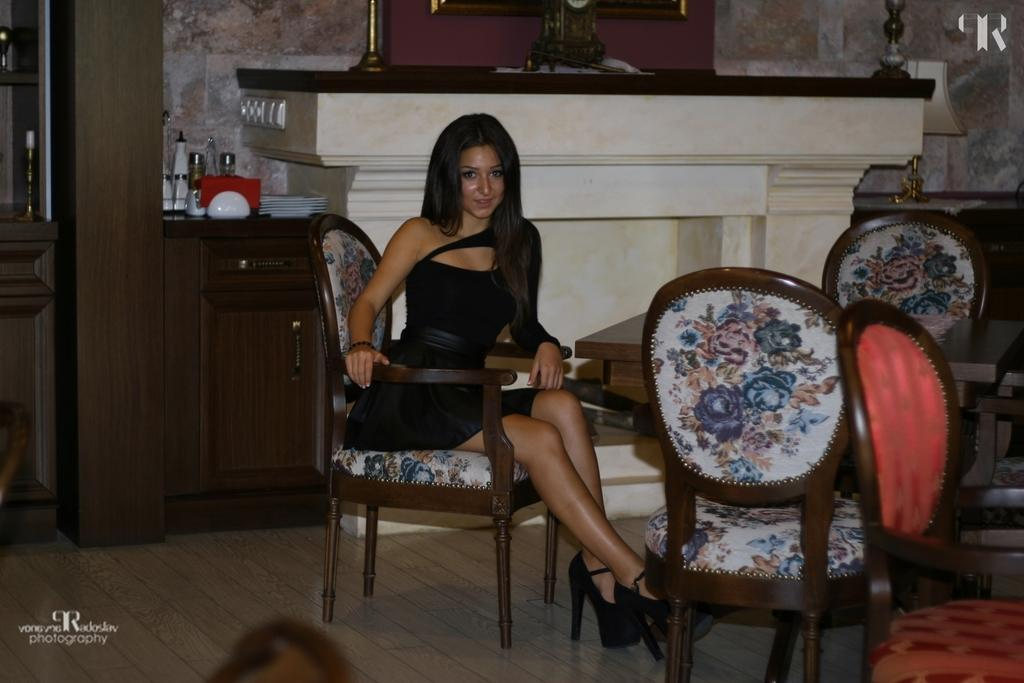Who is present in the image? There is a woman in the image. What is the woman doing in the image? The woman is seated on a chair. Are there any other chairs visible in the image? Yes, there are chairs around the woman. What piece of furniture is present in the image besides the chairs? There is a table in the image. Is the woman sinking in quicksand in the image? No, there is no quicksand present in the image. What type of drug is the woman taking in the image? There is no drug present in the image; the woman is simply seated on a chair. 